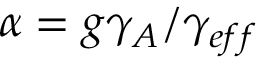<formula> <loc_0><loc_0><loc_500><loc_500>\alpha = g \gamma _ { A } / \gamma _ { e f f }</formula> 